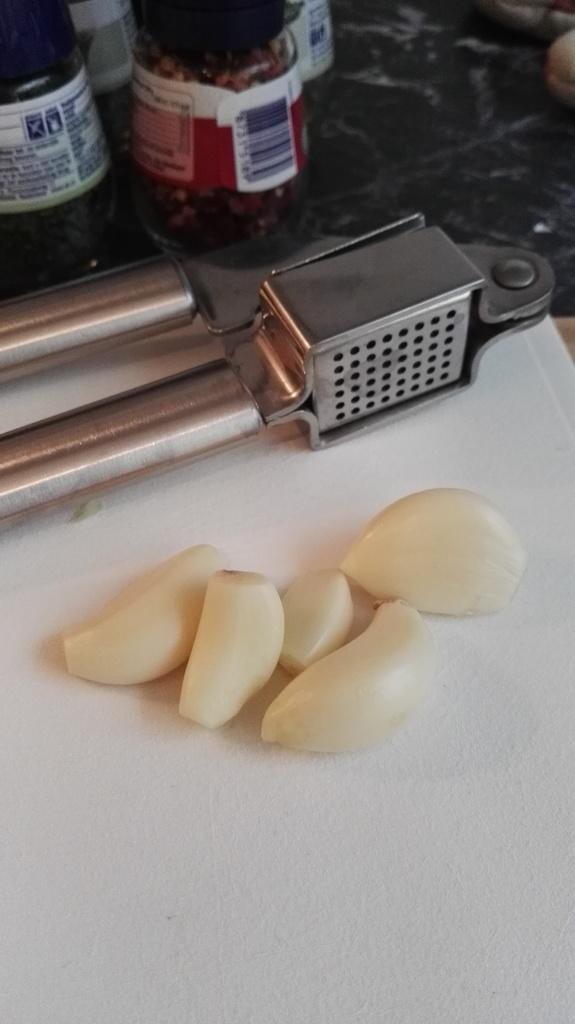What is placed on the paper in the image? There are garlic on a paper in the image. What tool is visible in the image? There is a slicer in the image. What type of surface is the bottles placed on? The bottles are placed on a stone slab in the image. Can you describe the snail's feelings as it crawls across the garlic in the image? There is no snail present in the image, so it is not possible to describe its feelings. 